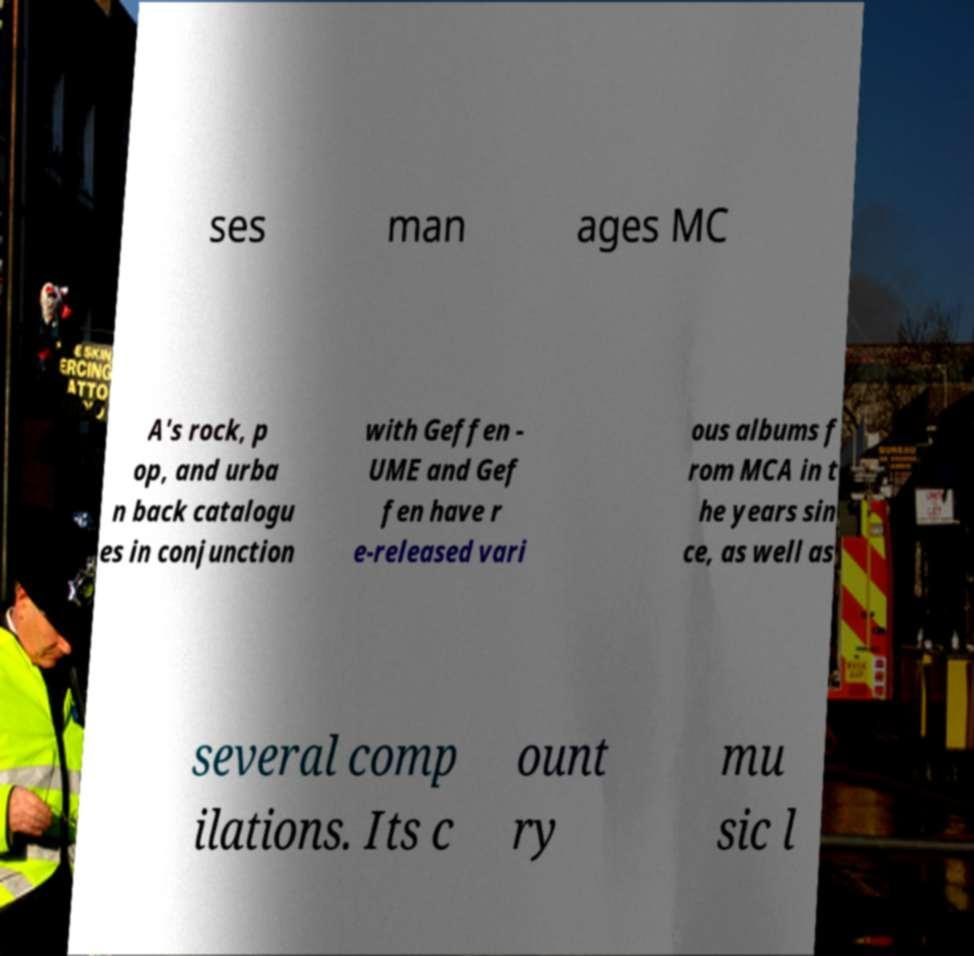I need the written content from this picture converted into text. Can you do that? ses man ages MC A's rock, p op, and urba n back catalogu es in conjunction with Geffen - UME and Gef fen have r e-released vari ous albums f rom MCA in t he years sin ce, as well as several comp ilations. Its c ount ry mu sic l 